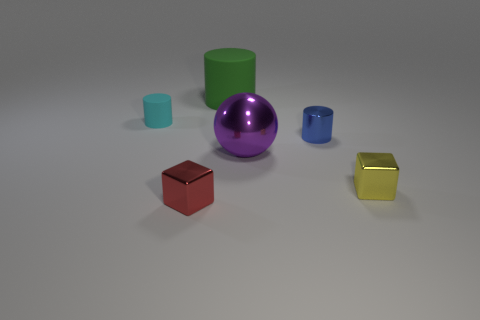There is a cyan object that is the same material as the large green object; what is its shape? The cyan object that shares the same glossy, plastic-like material as the large green object is shaped as a cylinder. 